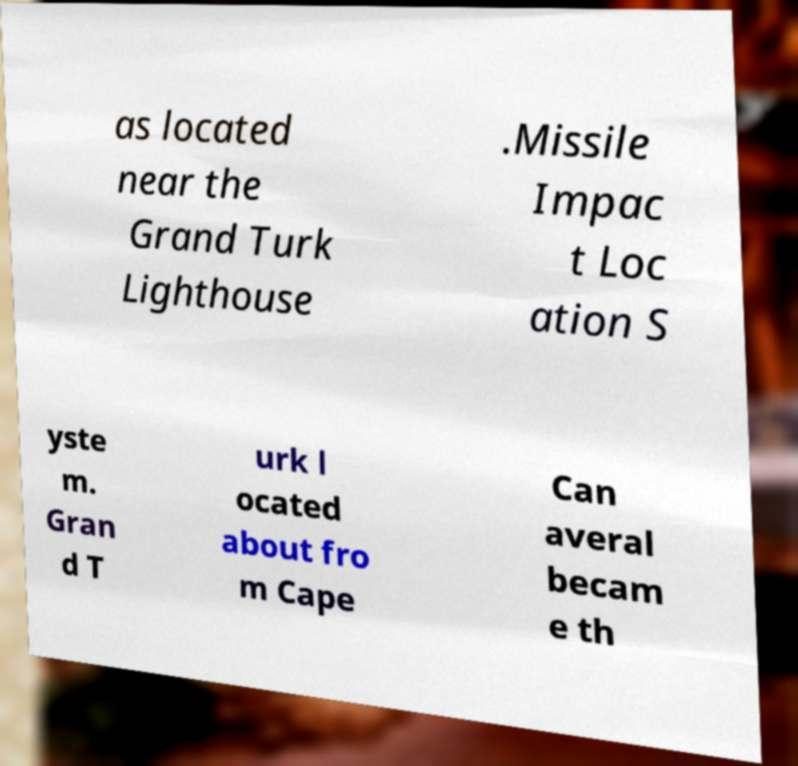Please identify and transcribe the text found in this image. as located near the Grand Turk Lighthouse .Missile Impac t Loc ation S yste m. Gran d T urk l ocated about fro m Cape Can averal becam e th 